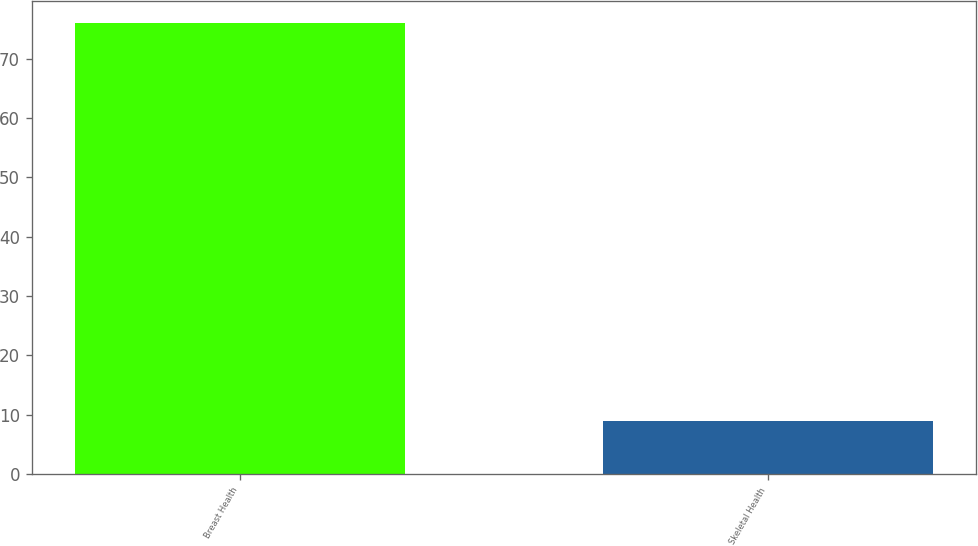Convert chart. <chart><loc_0><loc_0><loc_500><loc_500><bar_chart><fcel>Breast Health<fcel>Skeletal Health<nl><fcel>76<fcel>9<nl></chart> 